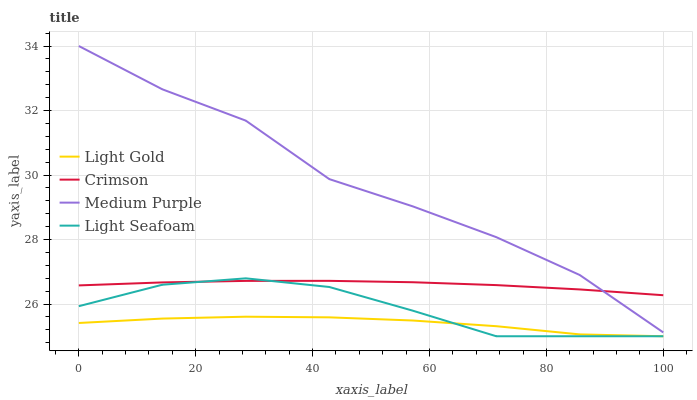Does Light Gold have the minimum area under the curve?
Answer yes or no. Yes. Does Medium Purple have the maximum area under the curve?
Answer yes or no. Yes. Does Light Seafoam have the minimum area under the curve?
Answer yes or no. No. Does Light Seafoam have the maximum area under the curve?
Answer yes or no. No. Is Crimson the smoothest?
Answer yes or no. Yes. Is Medium Purple the roughest?
Answer yes or no. Yes. Is Light Seafoam the smoothest?
Answer yes or no. No. Is Light Seafoam the roughest?
Answer yes or no. No. Does Light Seafoam have the lowest value?
Answer yes or no. Yes. Does Medium Purple have the lowest value?
Answer yes or no. No. Does Medium Purple have the highest value?
Answer yes or no. Yes. Does Light Seafoam have the highest value?
Answer yes or no. No. Is Light Gold less than Crimson?
Answer yes or no. Yes. Is Crimson greater than Light Gold?
Answer yes or no. Yes. Does Medium Purple intersect Crimson?
Answer yes or no. Yes. Is Medium Purple less than Crimson?
Answer yes or no. No. Is Medium Purple greater than Crimson?
Answer yes or no. No. Does Light Gold intersect Crimson?
Answer yes or no. No. 